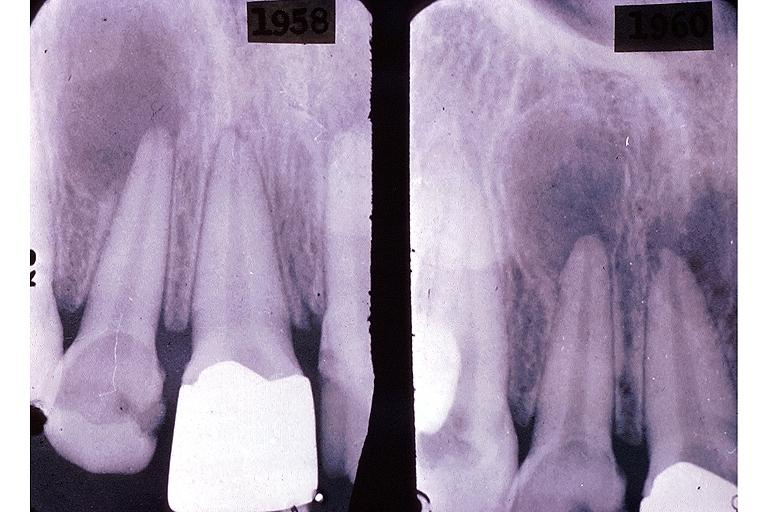does infarct show periapical granuloma?
Answer the question using a single word or phrase. No 